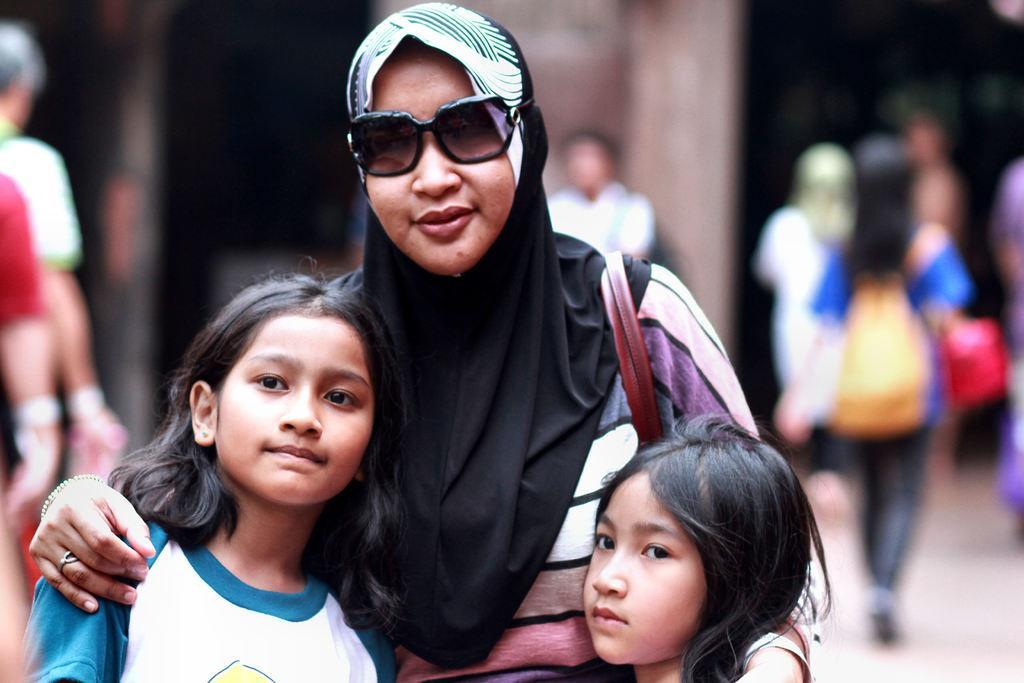Describe this image in one or two sentences. In this picture there are three people standing. In the background of the image it is blurry. 